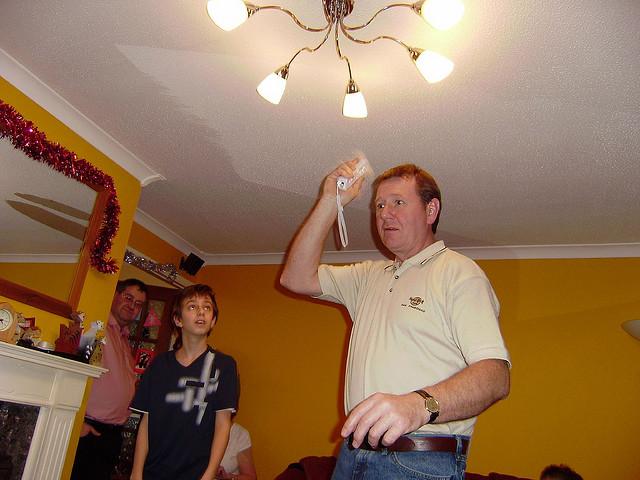What type of shirt is the man wearing?
Concise answer only. Polo. Are the lights on?
Short answer required. Yes. Are there any females?
Concise answer only. No. What color is the wall?
Be succinct. Yellow. 